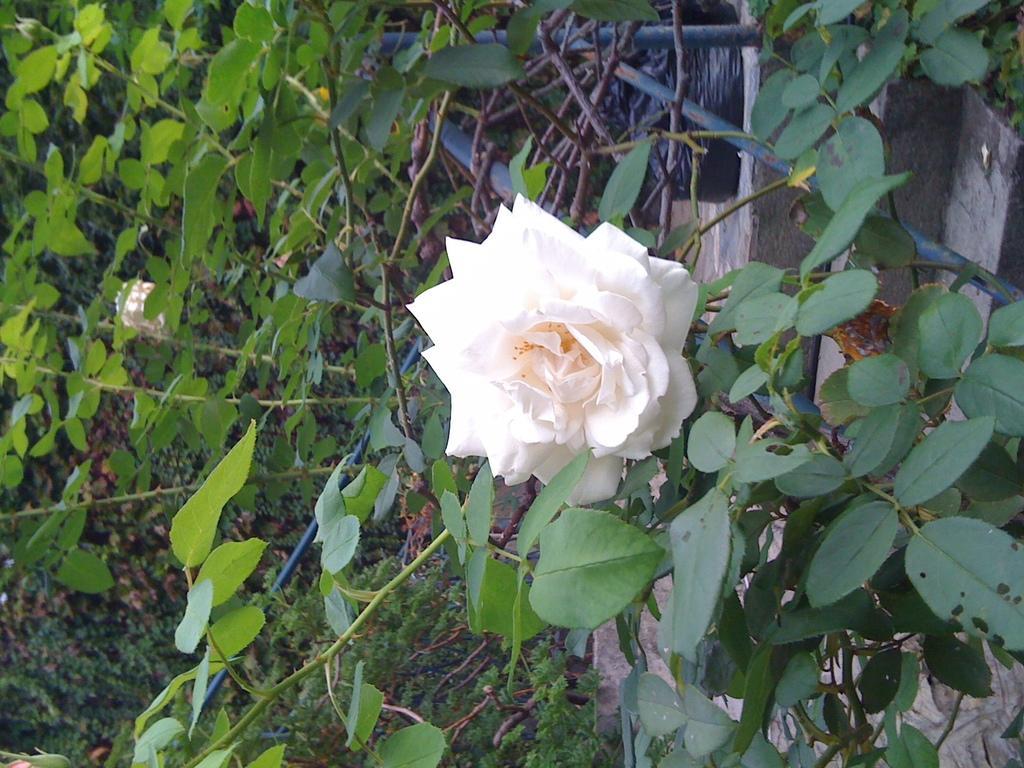Please provide a concise description of this image. In the picture we can see many plants with a flower which is white in color. 